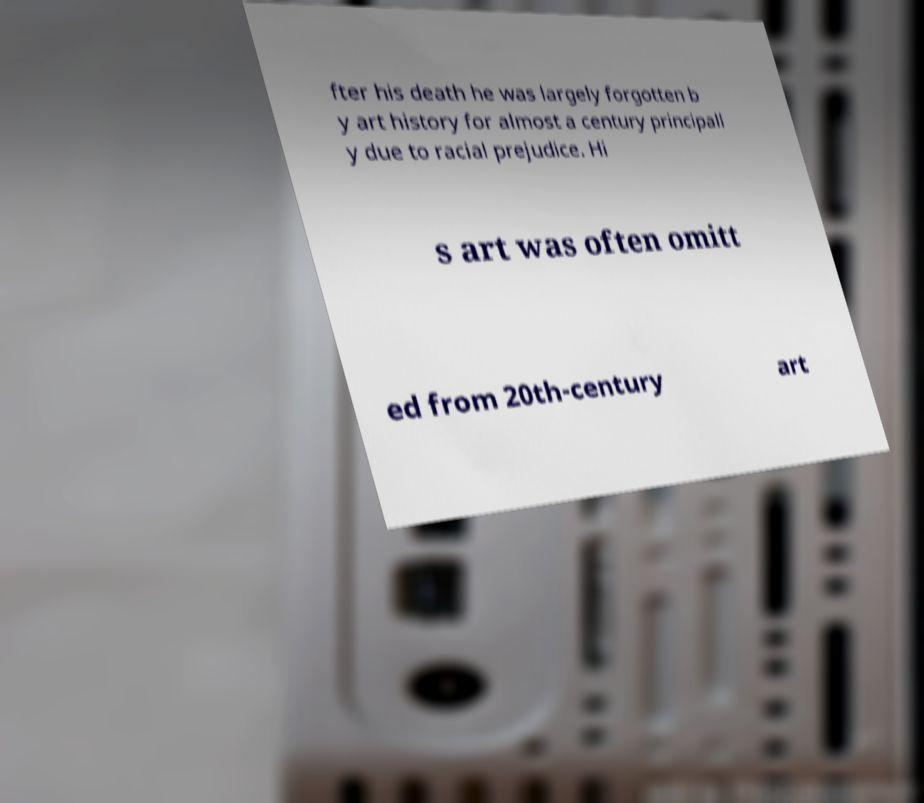Can you read and provide the text displayed in the image?This photo seems to have some interesting text. Can you extract and type it out for me? fter his death he was largely forgotten b y art history for almost a century principall y due to racial prejudice. Hi s art was often omitt ed from 20th-century art 